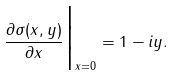Convert formula to latex. <formula><loc_0><loc_0><loc_500><loc_500>\frac { \partial \sigma ( x , y ) } { \partial x } \Big | _ { x = 0 } = 1 - i y .</formula> 